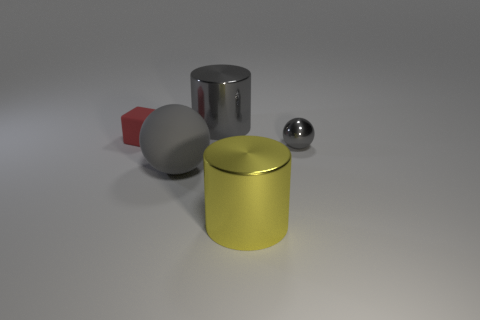Add 2 red matte objects. How many objects exist? 7 Subtract all balls. How many objects are left? 3 Add 1 cubes. How many cubes are left? 2 Add 3 large gray matte cylinders. How many large gray matte cylinders exist? 3 Subtract 0 blue cubes. How many objects are left? 5 Subtract all large shiny things. Subtract all big gray objects. How many objects are left? 1 